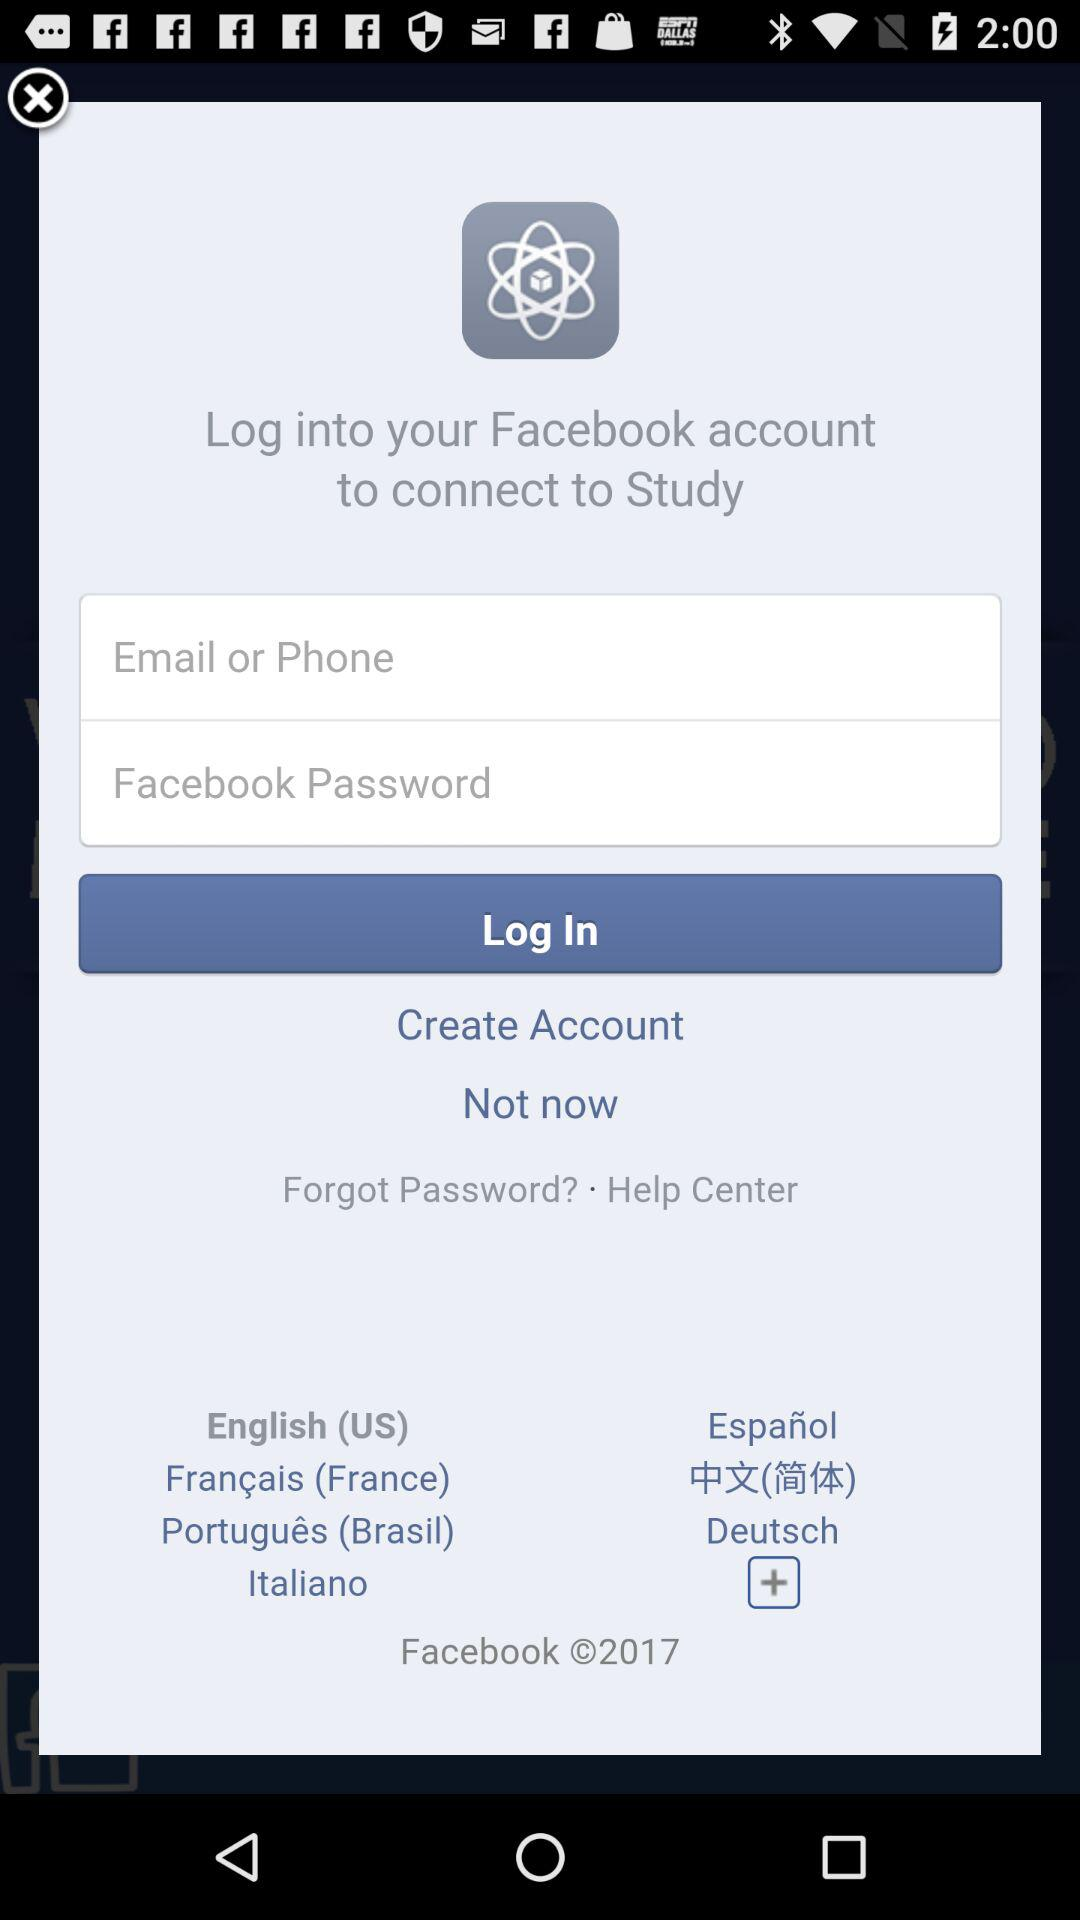Through what application can we log in to connect to "Study"? You can log in through "Facebook" to connect to "Study". 